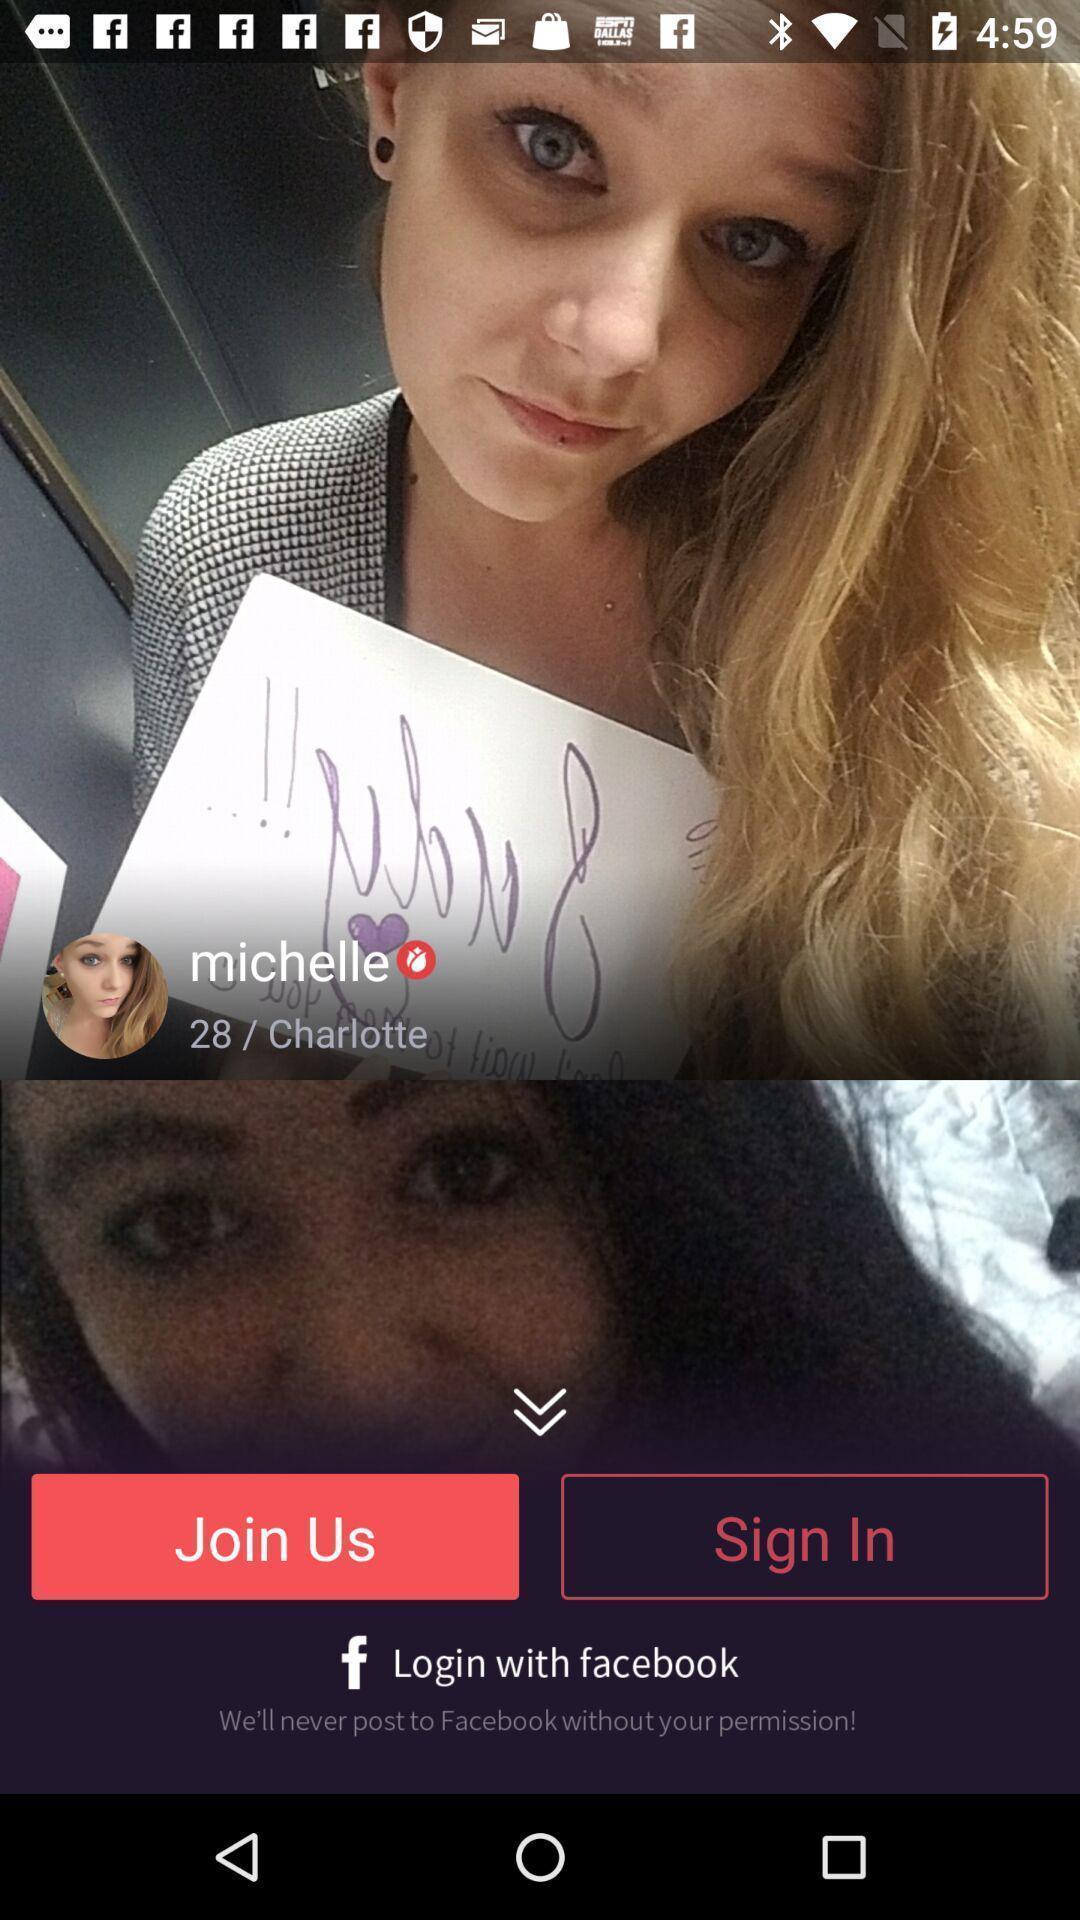Tell me what you see in this picture. Sign in page displayed. 